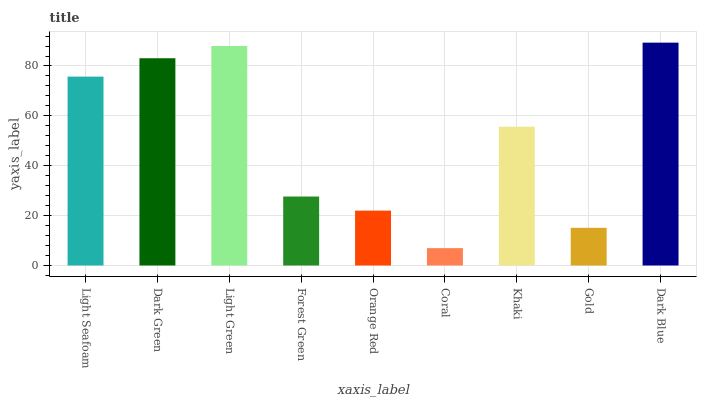Is Coral the minimum?
Answer yes or no. Yes. Is Dark Blue the maximum?
Answer yes or no. Yes. Is Dark Green the minimum?
Answer yes or no. No. Is Dark Green the maximum?
Answer yes or no. No. Is Dark Green greater than Light Seafoam?
Answer yes or no. Yes. Is Light Seafoam less than Dark Green?
Answer yes or no. Yes. Is Light Seafoam greater than Dark Green?
Answer yes or no. No. Is Dark Green less than Light Seafoam?
Answer yes or no. No. Is Khaki the high median?
Answer yes or no. Yes. Is Khaki the low median?
Answer yes or no. Yes. Is Coral the high median?
Answer yes or no. No. Is Gold the low median?
Answer yes or no. No. 